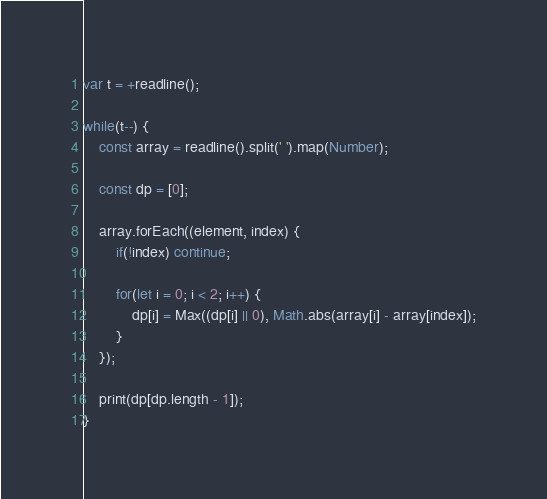Convert code to text. <code><loc_0><loc_0><loc_500><loc_500><_JavaScript_>var t = +readline();
 
while(t--) {
    const array = readline().split(' ').map(Number);
    
  	const dp = [0];
    
    array.forEach((element, index) {
		if(!index) continue;
  		
  		for(let i = 0; i < 2; i++) {
			dp[i] = Max((dp[i] || 0), Math.abs(array[i] - array[index]);
		}
	});
        
    print(dp[dp.length - 1]);
}</code> 